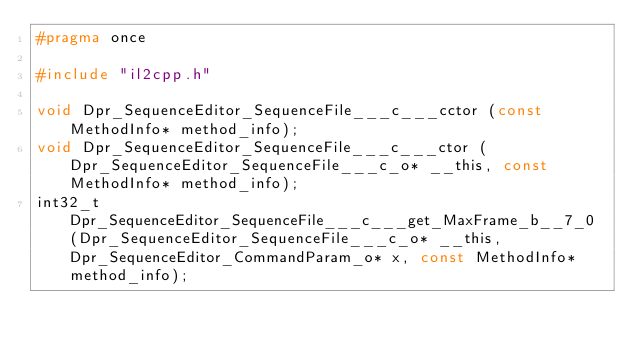Convert code to text. <code><loc_0><loc_0><loc_500><loc_500><_C_>#pragma once

#include "il2cpp.h"

void Dpr_SequenceEditor_SequenceFile___c___cctor (const MethodInfo* method_info);
void Dpr_SequenceEditor_SequenceFile___c___ctor (Dpr_SequenceEditor_SequenceFile___c_o* __this, const MethodInfo* method_info);
int32_t Dpr_SequenceEditor_SequenceFile___c___get_MaxFrame_b__7_0 (Dpr_SequenceEditor_SequenceFile___c_o* __this, Dpr_SequenceEditor_CommandParam_o* x, const MethodInfo* method_info);
</code> 